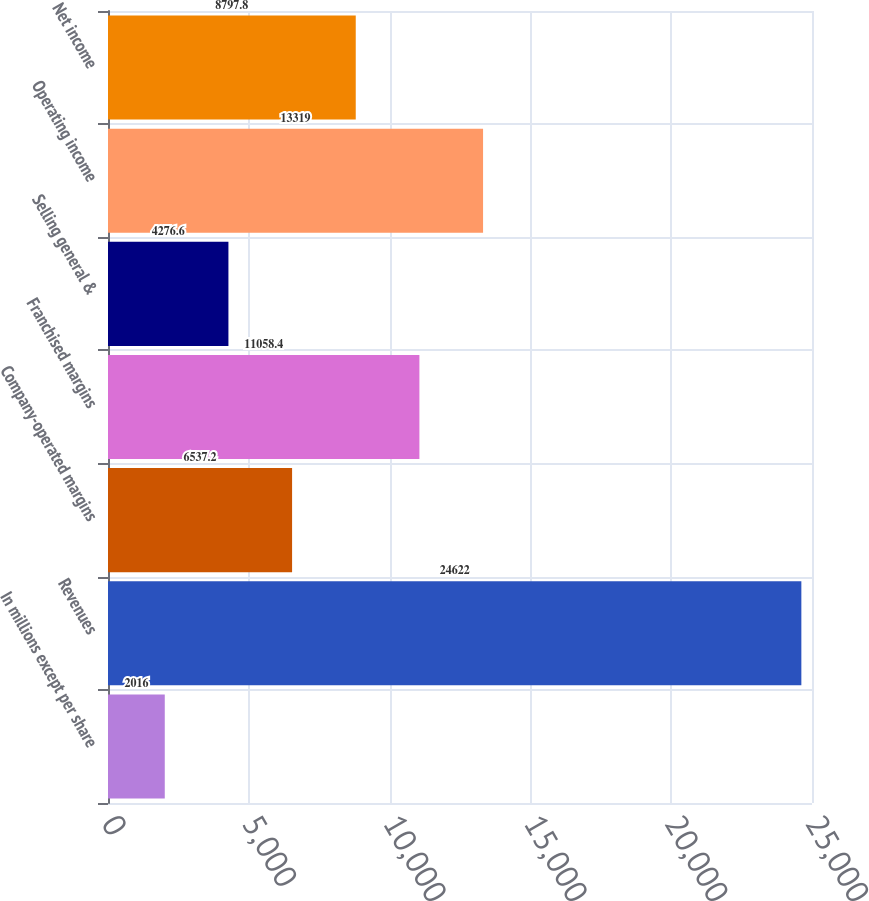<chart> <loc_0><loc_0><loc_500><loc_500><bar_chart><fcel>In millions except per share<fcel>Revenues<fcel>Company-operated margins<fcel>Franchised margins<fcel>Selling general &<fcel>Operating income<fcel>Net income<nl><fcel>2016<fcel>24622<fcel>6537.2<fcel>11058.4<fcel>4276.6<fcel>13319<fcel>8797.8<nl></chart> 